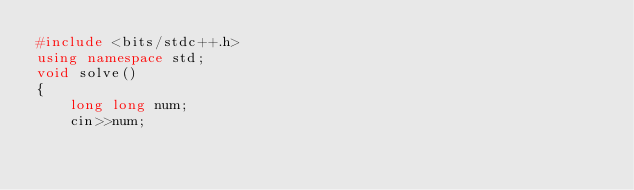Convert code to text. <code><loc_0><loc_0><loc_500><loc_500><_C++_>#include <bits/stdc++.h>
using namespace std;
void solve()
{
    long long num;
    cin>>num;
</code> 